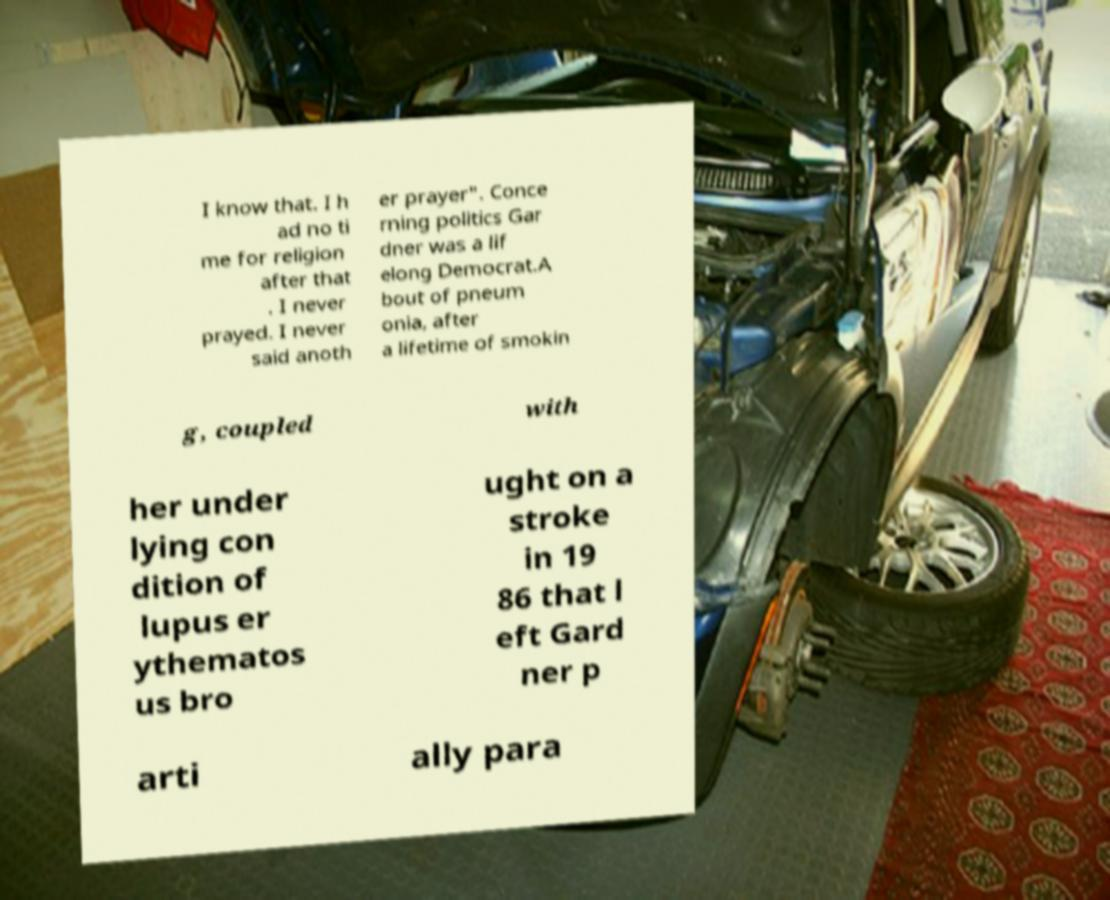For documentation purposes, I need the text within this image transcribed. Could you provide that? I know that. I h ad no ti me for religion after that . I never prayed. I never said anoth er prayer". Conce rning politics Gar dner was a lif elong Democrat.A bout of pneum onia, after a lifetime of smokin g, coupled with her under lying con dition of lupus er ythematos us bro ught on a stroke in 19 86 that l eft Gard ner p arti ally para 